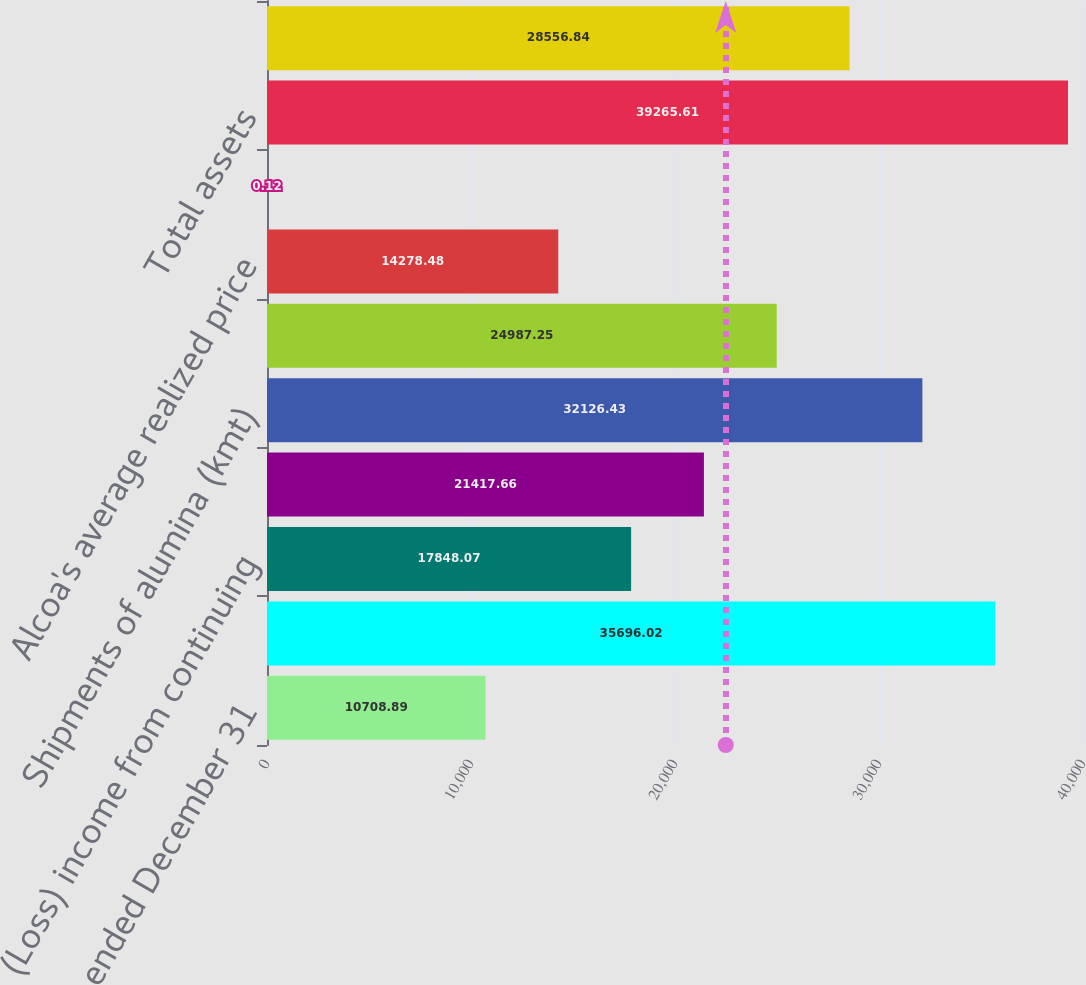<chart> <loc_0><loc_0><loc_500><loc_500><bar_chart><fcel>For the year ended December 31<fcel>Sales<fcel>(Loss) income from continuing<fcel>Net (loss) income<fcel>Shipments of alumina (kmt)<fcel>Shipments of aluminum products<fcel>Alcoa's average realized price<fcel>Cash dividends declared per<fcel>Total assets<fcel>Total debt<nl><fcel>10708.9<fcel>35696<fcel>17848.1<fcel>21417.7<fcel>32126.4<fcel>24987.2<fcel>14278.5<fcel>0.12<fcel>39265.6<fcel>28556.8<nl></chart> 